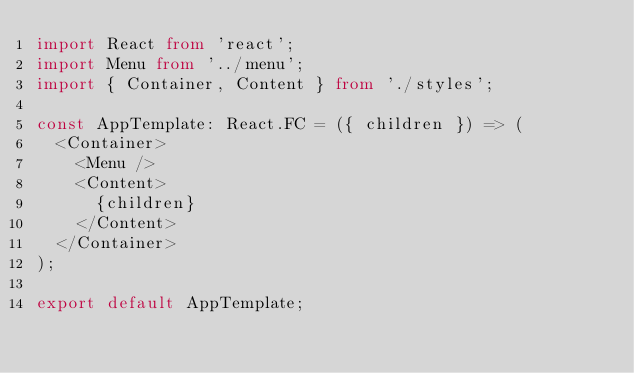Convert code to text. <code><loc_0><loc_0><loc_500><loc_500><_TypeScript_>import React from 'react';
import Menu from '../menu';
import { Container, Content } from './styles';

const AppTemplate: React.FC = ({ children }) => (
  <Container>
    <Menu />
    <Content>
      {children}
    </Content>
  </Container>
);

export default AppTemplate;
</code> 